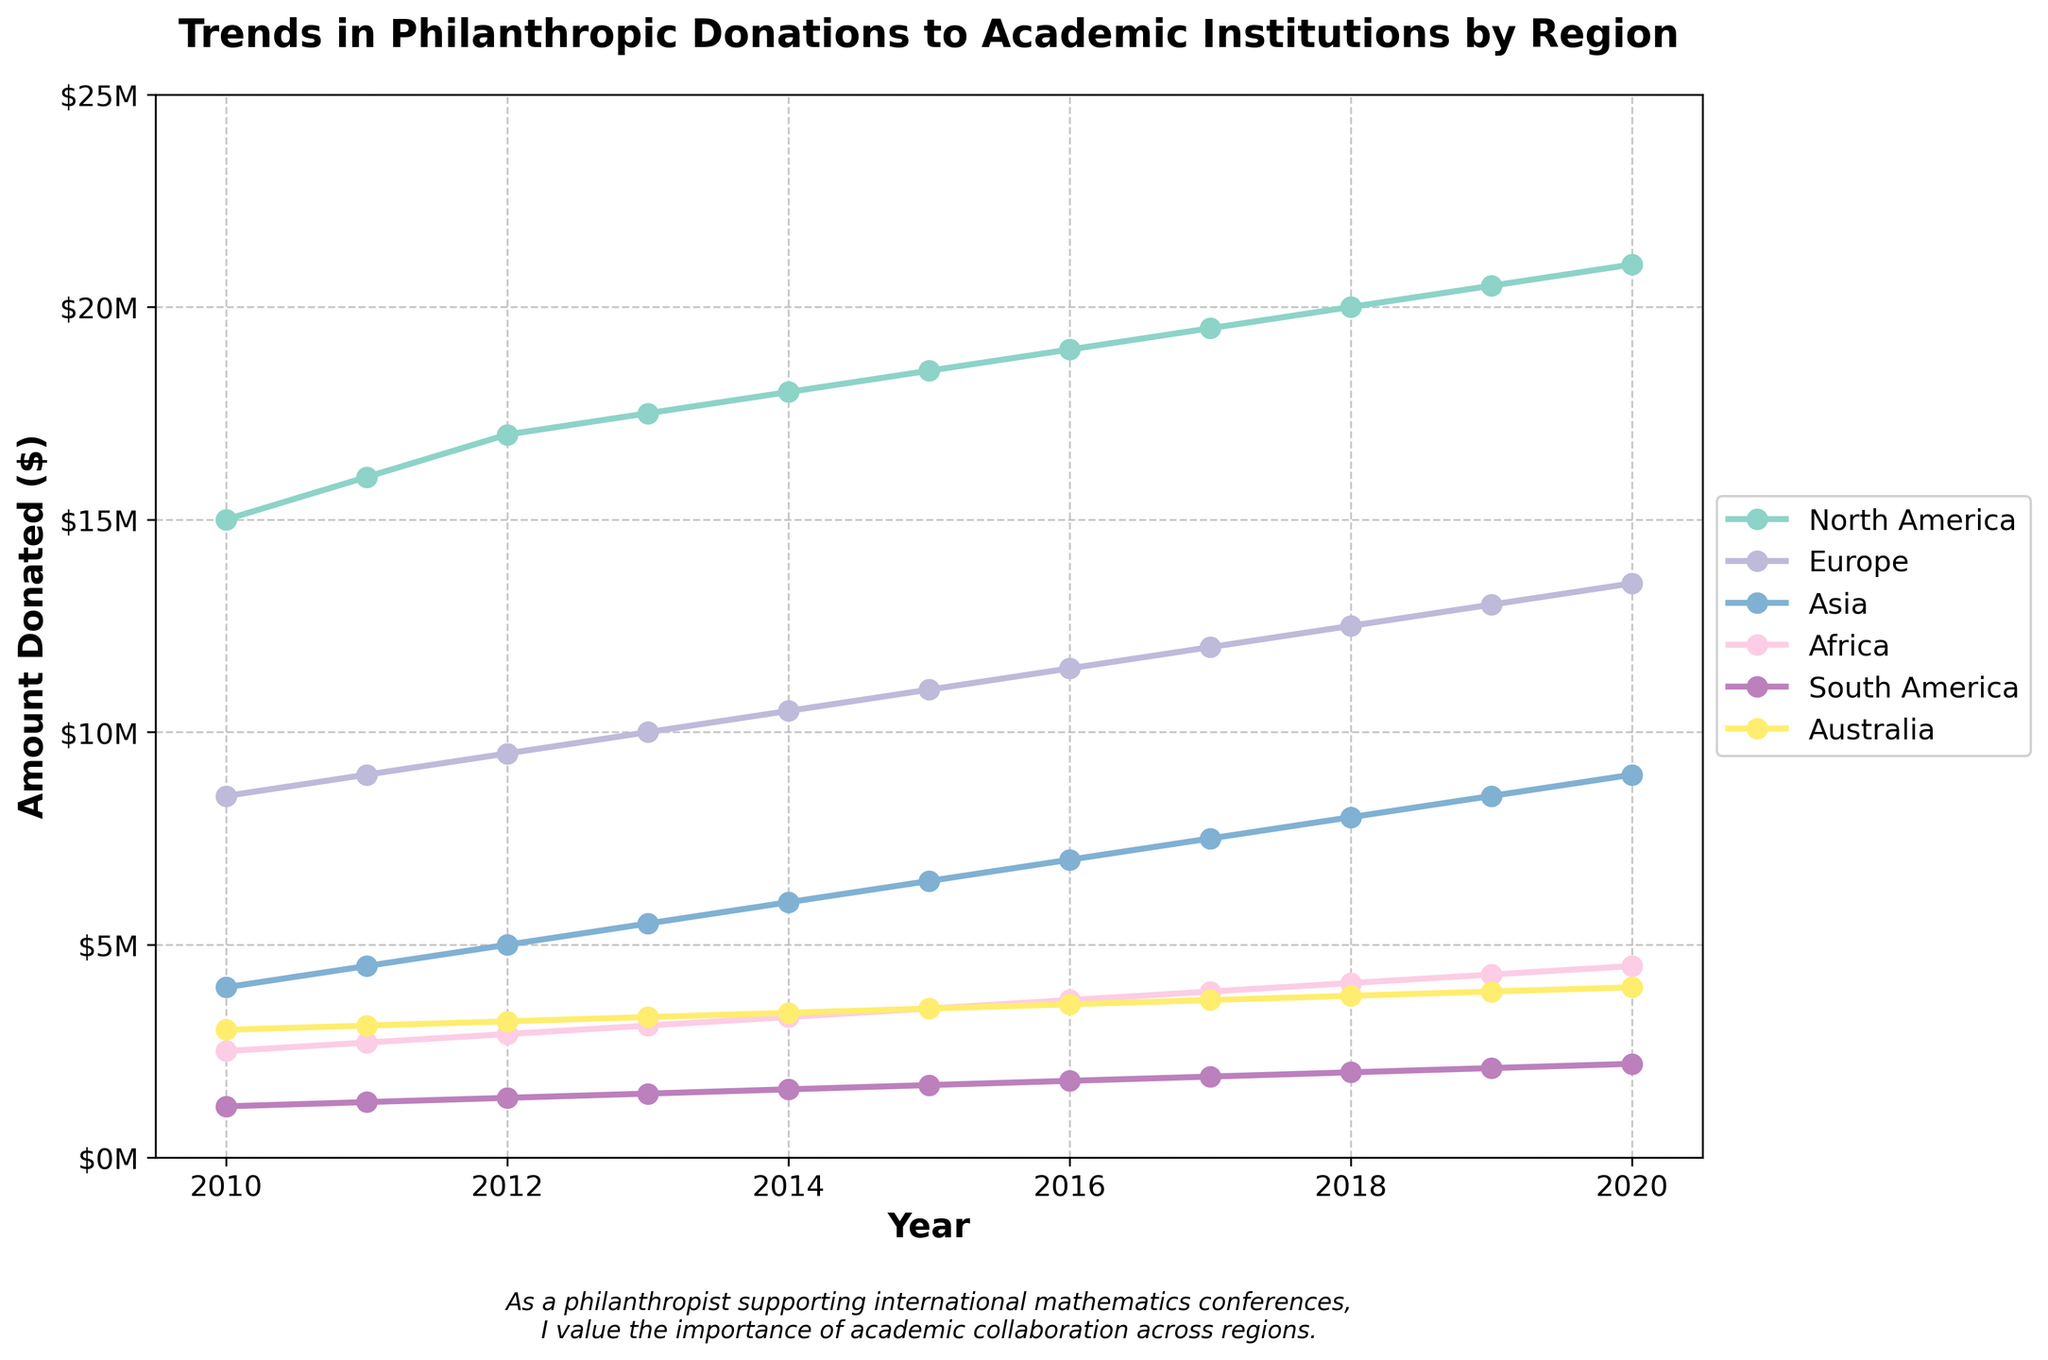When did North America receive the highest amount of donations? To determine the year North America received the highest amount of donations, look at the data points of the North America time series and identify the peak value. The peak amount is $21M in 2020.
Answer: 2020 Which region saw the greatest increase in donations from 2010 to 2020? Calculate the difference in donation amounts for each region between 2010 and 2020. North America saw an increase from $15M (2010) to $21M (2020), an increase of $6M. Europe saw an increase from $8.5M to $13.5M, an increase of $5M. Asia saw an increase from $4M to $9M, an increase of $5M. Africa saw an increase from $2.5M to $4.5M, an increase of $2M. South America saw an increase from $1.2M to $2.2M, an increase of $1M. Australia saw an increase from $3M to $4M, an increase of $1M. North America had the greatest increase of $6M.
Answer: North America By how much did the donations to Asia increase from 2012 to 2018? Calculate the difference between the donation amounts in 2012 and 2018 for Asia. In 2012, Asia received $5M, and in 2018, it received $8M. The increase is $8M - $5M = $3M.
Answer: $3M Which region had the lowest donations in the latest year shown in the plot? Look at the donation amounts for each region in the year 2020. South America had the lowest amount with $2.2M.
Answer: South America What was the total amount donated across all regions in 2015? Sum the donation amounts for all regions in 2015. The amounts are North America: $18.5M, Europe: $11M, Asia: $6.5M, Africa: $3.5M, South America: $1.7M, and Australia: $3.5M. Total = $18.5M + $11M + $6.5M + $3.5M + $1.7M + $3.5M = $44.7M.
Answer: $44.7M Did donations to Africa ever surpass donations to Asia in the given time frame? Examine the plotted lines for Africa and Asia across the years. Africa's donations never exceed Asia's donations in any year between 2010 and 2020 on the plot.
Answer: No How did the donations to Europe change in the 2010s? Observe the plotted line for Europe from 2010 to 2020. Donations to Europe increased consistently every year from $8.5M in 2010 to $13.5M in 2020.
Answer: Increased every year Which year shows the highest donation amount for all regions combined? Compare the total donations for each year by summing the donation amounts across all regions for each year. The highest total is in 2020 with a combined amount across all regions higher than previous years.
Answer: 2020 Which two regions show the most similar donation trends? Examine the slope and shape of the lines for all regions to find the two that move similarly. Europe and Asia show similar trends, both showing a steady increase over the years, although the actual amounts differ.
Answer: Europe and Asia 